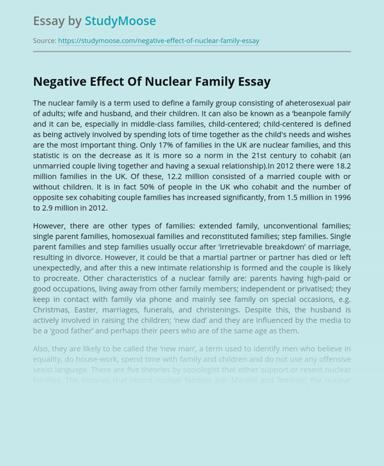How does the essay address the role of economic factors in the evolution of family structures? The essay discusses how economic factors, like fluctuating employment rates and changes in economic stability, play a crucial role in shaping family structures. It argues that economic pressures can lead to both the formation and dissolution of family units, affecting decisions on marriage, cohabitation, and child-rearing among couples. 